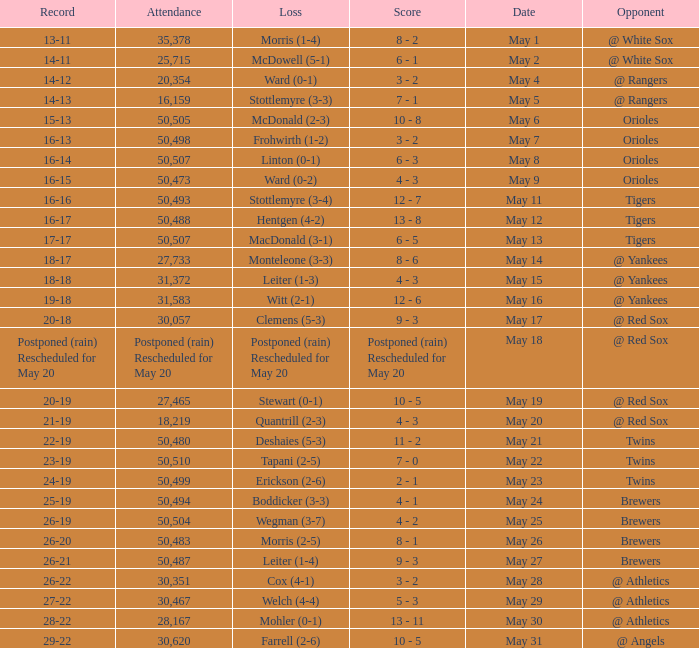On may 29, which group suffered the loss? Welch (4-4). Parse the full table. {'header': ['Record', 'Attendance', 'Loss', 'Score', 'Date', 'Opponent'], 'rows': [['13-11', '35,378', 'Morris (1-4)', '8 - 2', 'May 1', '@ White Sox'], ['14-11', '25,715', 'McDowell (5-1)', '6 - 1', 'May 2', '@ White Sox'], ['14-12', '20,354', 'Ward (0-1)', '3 - 2', 'May 4', '@ Rangers'], ['14-13', '16,159', 'Stottlemyre (3-3)', '7 - 1', 'May 5', '@ Rangers'], ['15-13', '50,505', 'McDonald (2-3)', '10 - 8', 'May 6', 'Orioles'], ['16-13', '50,498', 'Frohwirth (1-2)', '3 - 2', 'May 7', 'Orioles'], ['16-14', '50,507', 'Linton (0-1)', '6 - 3', 'May 8', 'Orioles'], ['16-15', '50,473', 'Ward (0-2)', '4 - 3', 'May 9', 'Orioles'], ['16-16', '50,493', 'Stottlemyre (3-4)', '12 - 7', 'May 11', 'Tigers'], ['16-17', '50,488', 'Hentgen (4-2)', '13 - 8', 'May 12', 'Tigers'], ['17-17', '50,507', 'MacDonald (3-1)', '6 - 5', 'May 13', 'Tigers'], ['18-17', '27,733', 'Monteleone (3-3)', '8 - 6', 'May 14', '@ Yankees'], ['18-18', '31,372', 'Leiter (1-3)', '4 - 3', 'May 15', '@ Yankees'], ['19-18', '31,583', 'Witt (2-1)', '12 - 6', 'May 16', '@ Yankees'], ['20-18', '30,057', 'Clemens (5-3)', '9 - 3', 'May 17', '@ Red Sox'], ['Postponed (rain) Rescheduled for May 20', 'Postponed (rain) Rescheduled for May 20', 'Postponed (rain) Rescheduled for May 20', 'Postponed (rain) Rescheduled for May 20', 'May 18', '@ Red Sox'], ['20-19', '27,465', 'Stewart (0-1)', '10 - 5', 'May 19', '@ Red Sox'], ['21-19', '18,219', 'Quantrill (2-3)', '4 - 3', 'May 20', '@ Red Sox'], ['22-19', '50,480', 'Deshaies (5-3)', '11 - 2', 'May 21', 'Twins'], ['23-19', '50,510', 'Tapani (2-5)', '7 - 0', 'May 22', 'Twins'], ['24-19', '50,499', 'Erickson (2-6)', '2 - 1', 'May 23', 'Twins'], ['25-19', '50,494', 'Boddicker (3-3)', '4 - 1', 'May 24', 'Brewers'], ['26-19', '50,504', 'Wegman (3-7)', '4 - 2', 'May 25', 'Brewers'], ['26-20', '50,483', 'Morris (2-5)', '8 - 1', 'May 26', 'Brewers'], ['26-21', '50,487', 'Leiter (1-4)', '9 - 3', 'May 27', 'Brewers'], ['26-22', '30,351', 'Cox (4-1)', '3 - 2', 'May 28', '@ Athletics'], ['27-22', '30,467', 'Welch (4-4)', '5 - 3', 'May 29', '@ Athletics'], ['28-22', '28,167', 'Mohler (0-1)', '13 - 11', 'May 30', '@ Athletics'], ['29-22', '30,620', 'Farrell (2-6)', '10 - 5', 'May 31', '@ Angels']]} 